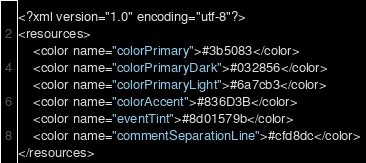Convert code to text. <code><loc_0><loc_0><loc_500><loc_500><_XML_><?xml version="1.0" encoding="utf-8"?>
<resources>
    <color name="colorPrimary">#3b5083</color>
    <color name="colorPrimaryDark">#032856</color>
    <color name="colorPrimaryLight">#6a7cb3</color>
    <color name="colorAccent">#836D3B</color>
    <color name="eventTint">#8d01579b</color>
    <color name="commentSeparationLine">#cfd8dc</color>
</resources>
</code> 